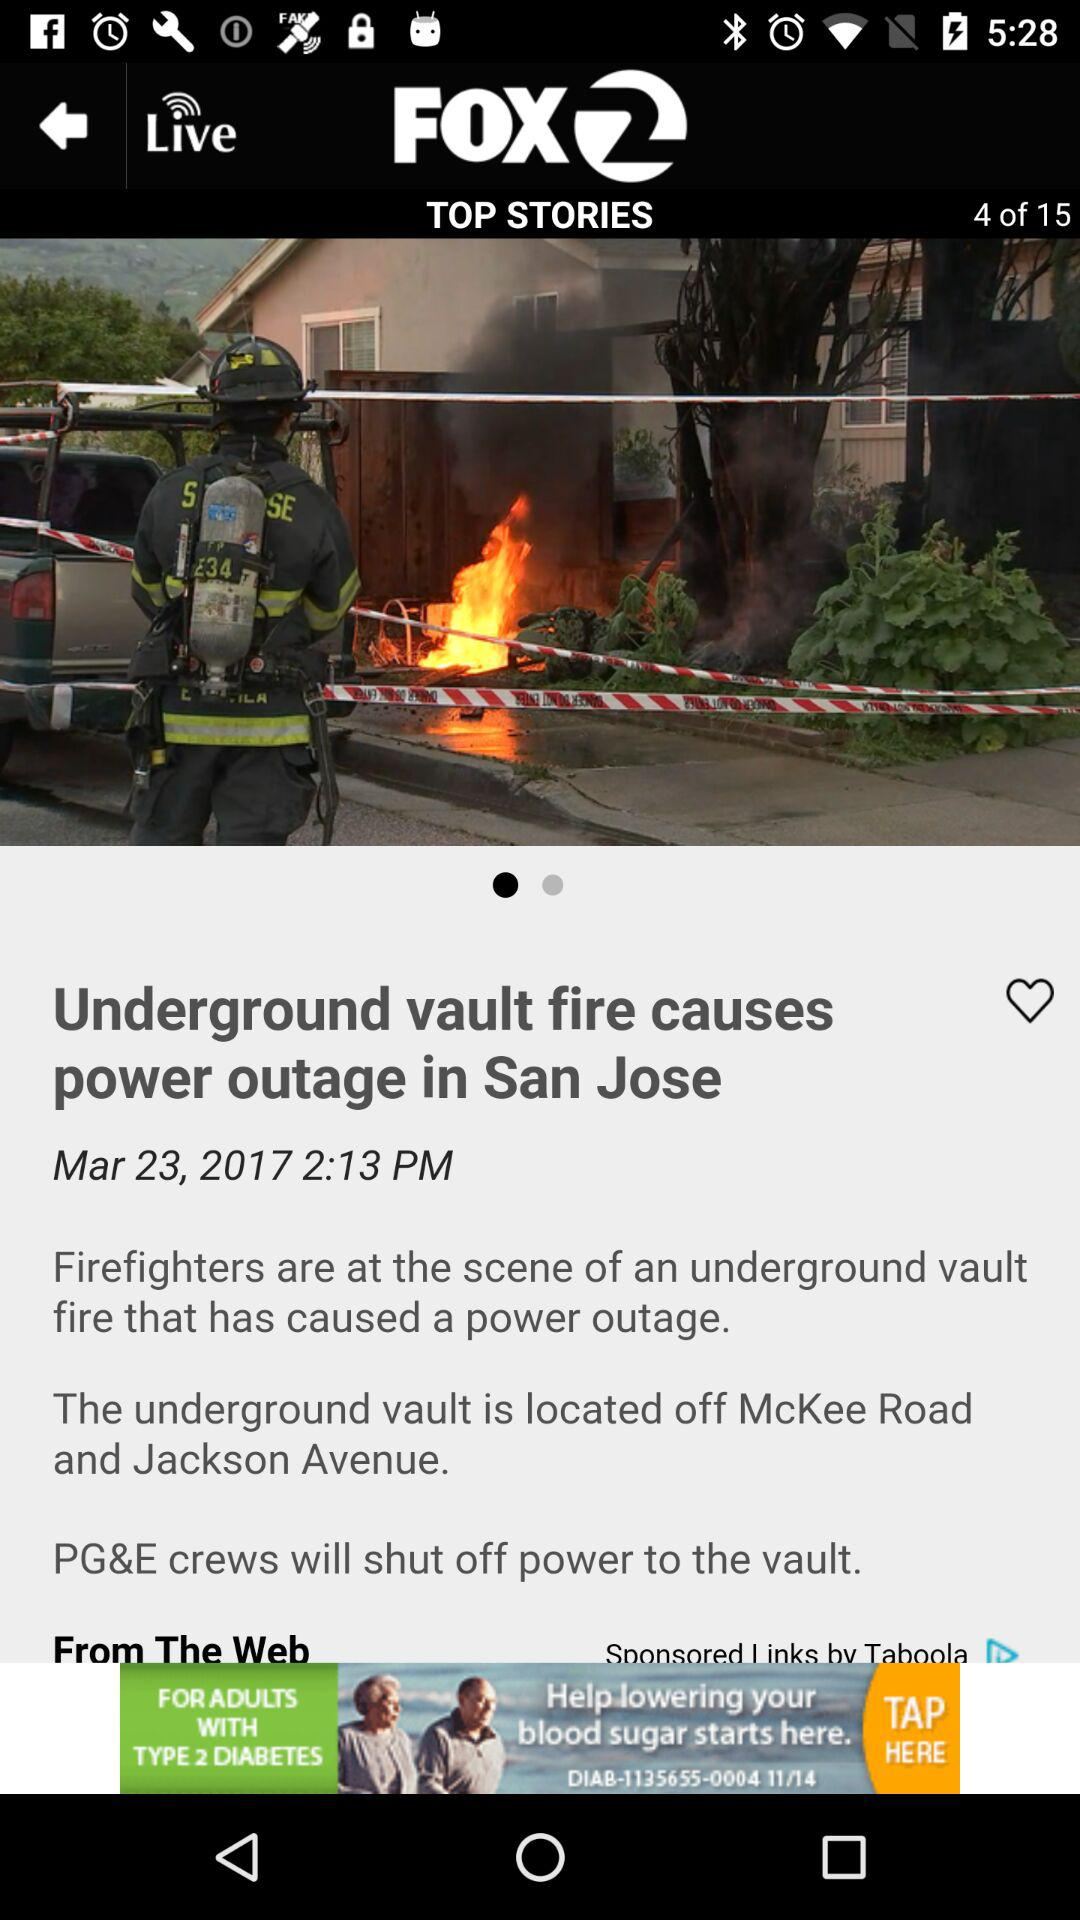What is the location of underground vault?
When the provided information is insufficient, respond with <no answer>. <no answer> 